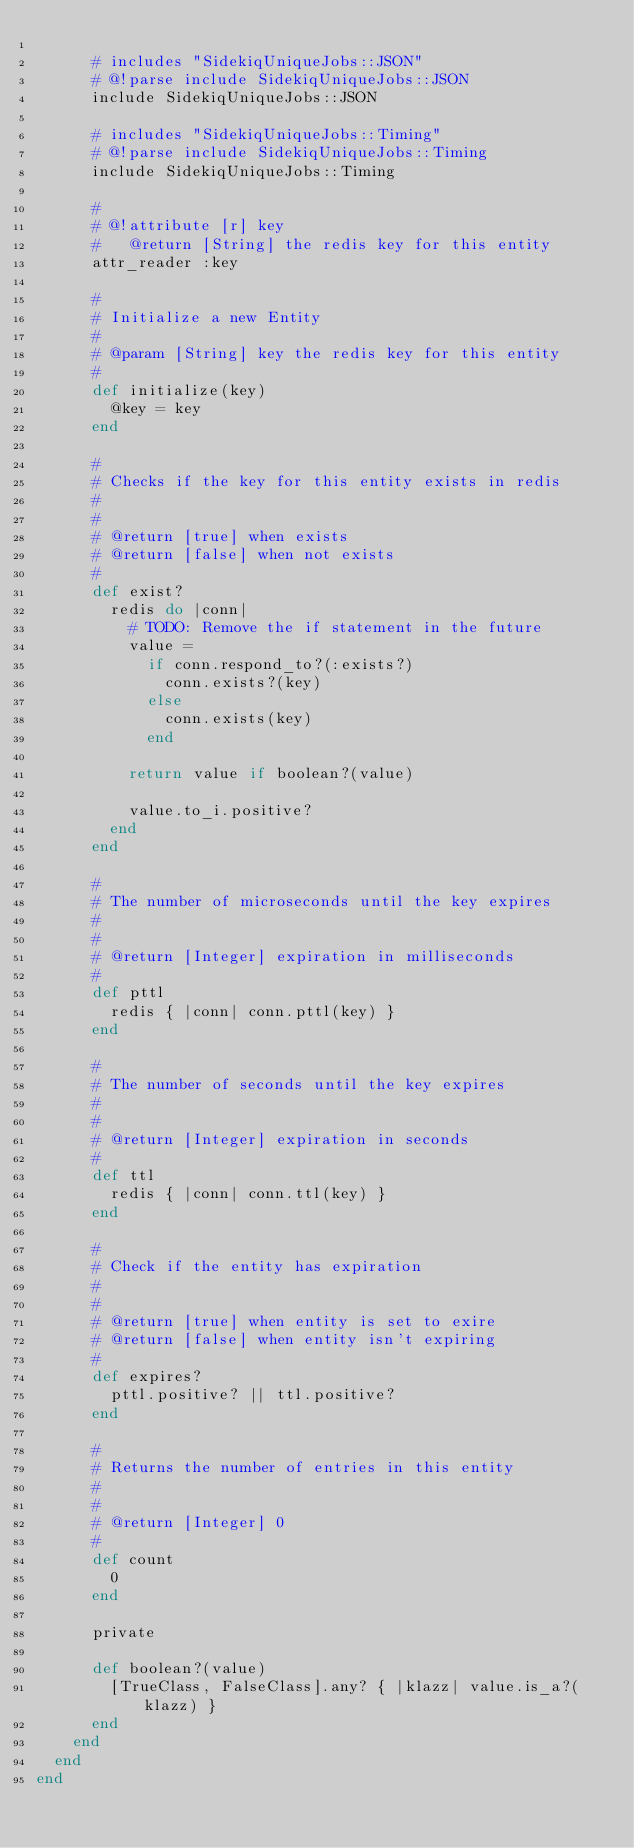<code> <loc_0><loc_0><loc_500><loc_500><_Ruby_>
      # includes "SidekiqUniqueJobs::JSON"
      # @!parse include SidekiqUniqueJobs::JSON
      include SidekiqUniqueJobs::JSON

      # includes "SidekiqUniqueJobs::Timing"
      # @!parse include SidekiqUniqueJobs::Timing
      include SidekiqUniqueJobs::Timing

      #
      # @!attribute [r] key
      #   @return [String] the redis key for this entity
      attr_reader :key

      #
      # Initialize a new Entity
      #
      # @param [String] key the redis key for this entity
      #
      def initialize(key)
        @key = key
      end

      #
      # Checks if the key for this entity exists in redis
      #
      #
      # @return [true] when exists
      # @return [false] when not exists
      #
      def exist?
        redis do |conn|
          # TODO: Remove the if statement in the future
          value =
            if conn.respond_to?(:exists?)
              conn.exists?(key)
            else
              conn.exists(key)
            end

          return value if boolean?(value)

          value.to_i.positive?
        end
      end

      #
      # The number of microseconds until the key expires
      #
      #
      # @return [Integer] expiration in milliseconds
      #
      def pttl
        redis { |conn| conn.pttl(key) }
      end

      #
      # The number of seconds until the key expires
      #
      #
      # @return [Integer] expiration in seconds
      #
      def ttl
        redis { |conn| conn.ttl(key) }
      end

      #
      # Check if the entity has expiration
      #
      #
      # @return [true] when entity is set to exire
      # @return [false] when entity isn't expiring
      #
      def expires?
        pttl.positive? || ttl.positive?
      end

      #
      # Returns the number of entries in this entity
      #
      #
      # @return [Integer] 0
      #
      def count
        0
      end

      private

      def boolean?(value)
        [TrueClass, FalseClass].any? { |klazz| value.is_a?(klazz) }
      end
    end
  end
end
</code> 